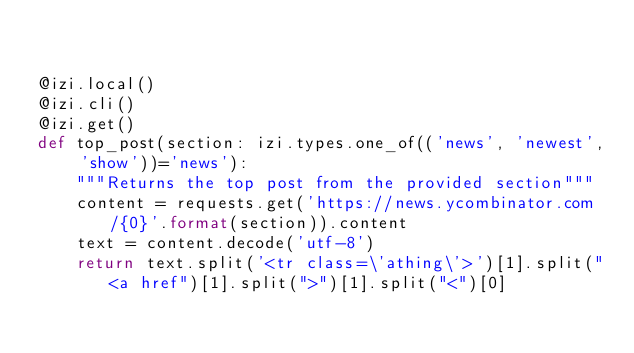<code> <loc_0><loc_0><loc_500><loc_500><_Python_>

@izi.local()
@izi.cli()
@izi.get()
def top_post(section: izi.types.one_of(('news', 'newest', 'show'))='news'):
    """Returns the top post from the provided section"""
    content = requests.get('https://news.ycombinator.com/{0}'.format(section)).content
    text = content.decode('utf-8')
    return text.split('<tr class=\'athing\'>')[1].split("<a href")[1].split(">")[1].split("<")[0]
</code> 